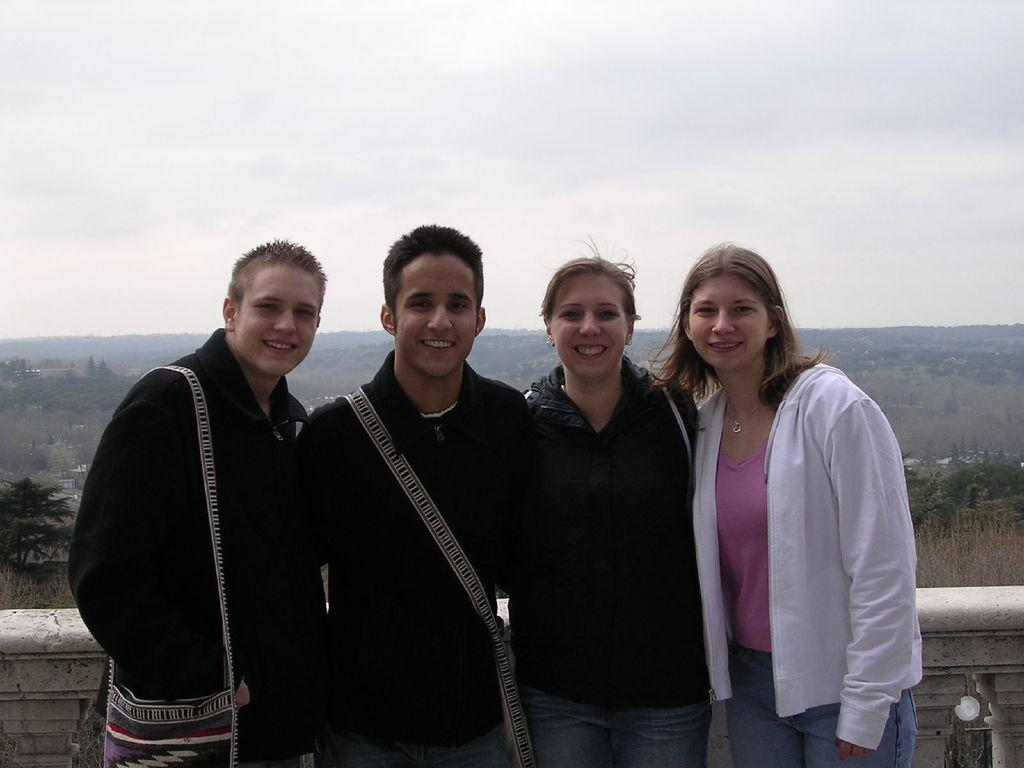How many people are present in the image? There are four persons standing in the image. What are the people doing in the image? The persons are standing at a fence. What can be seen in the background of the image? There are trees, buildings, and the sky visible in the background of the image. What type of pie is being served on the fence in the image? There is no pie present in the image; the people are standing at a fence. How many nails can be seen holding the fence together in the image? There is no mention of nails in the image; the focus is on the people standing at the fence. 